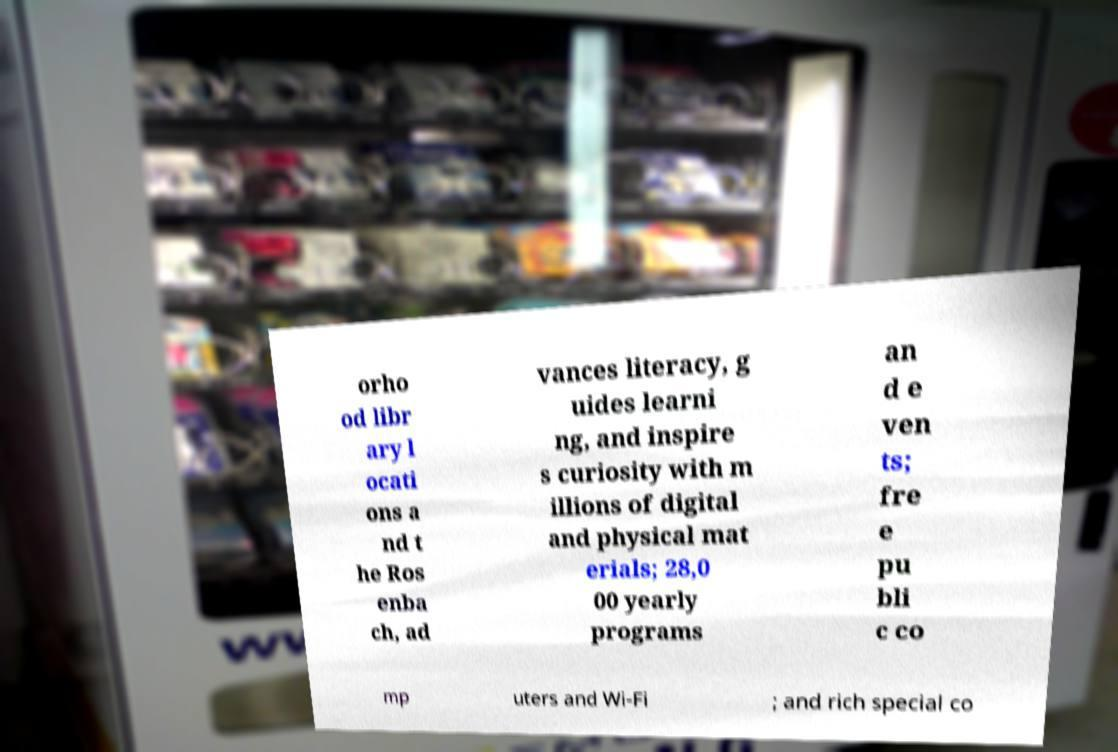Can you accurately transcribe the text from the provided image for me? orho od libr ary l ocati ons a nd t he Ros enba ch, ad vances literacy, g uides learni ng, and inspire s curiosity with m illions of digital and physical mat erials; 28,0 00 yearly programs an d e ven ts; fre e pu bli c co mp uters and Wi-Fi ; and rich special co 